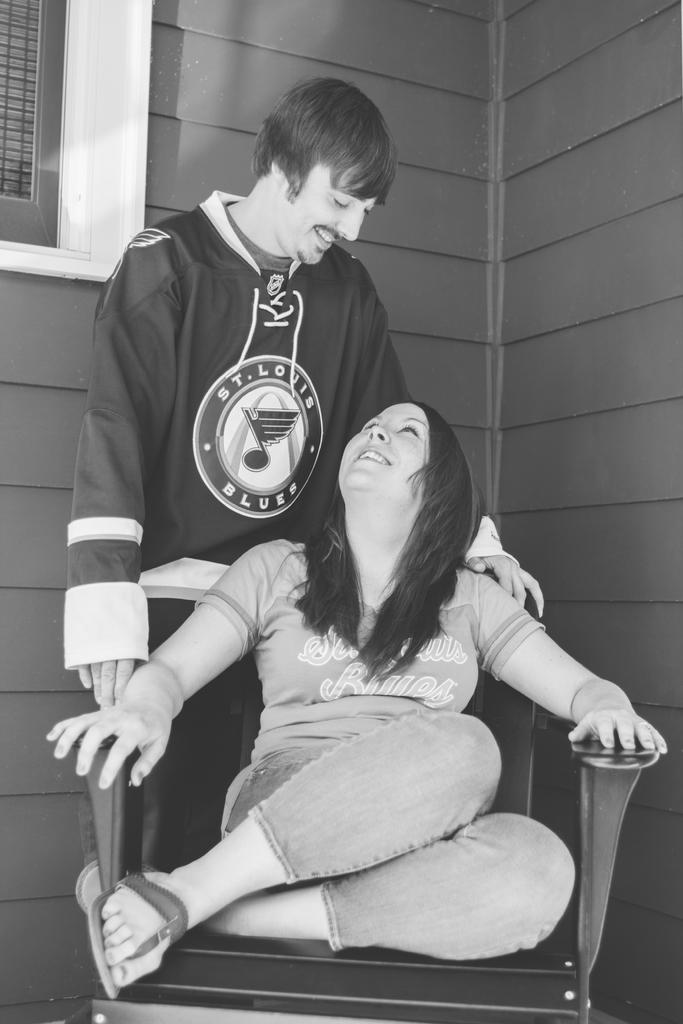Provide a one-sentence caption for the provided image. A man wearing a St Louis Blues shirt looks down at a woman on a chair. 